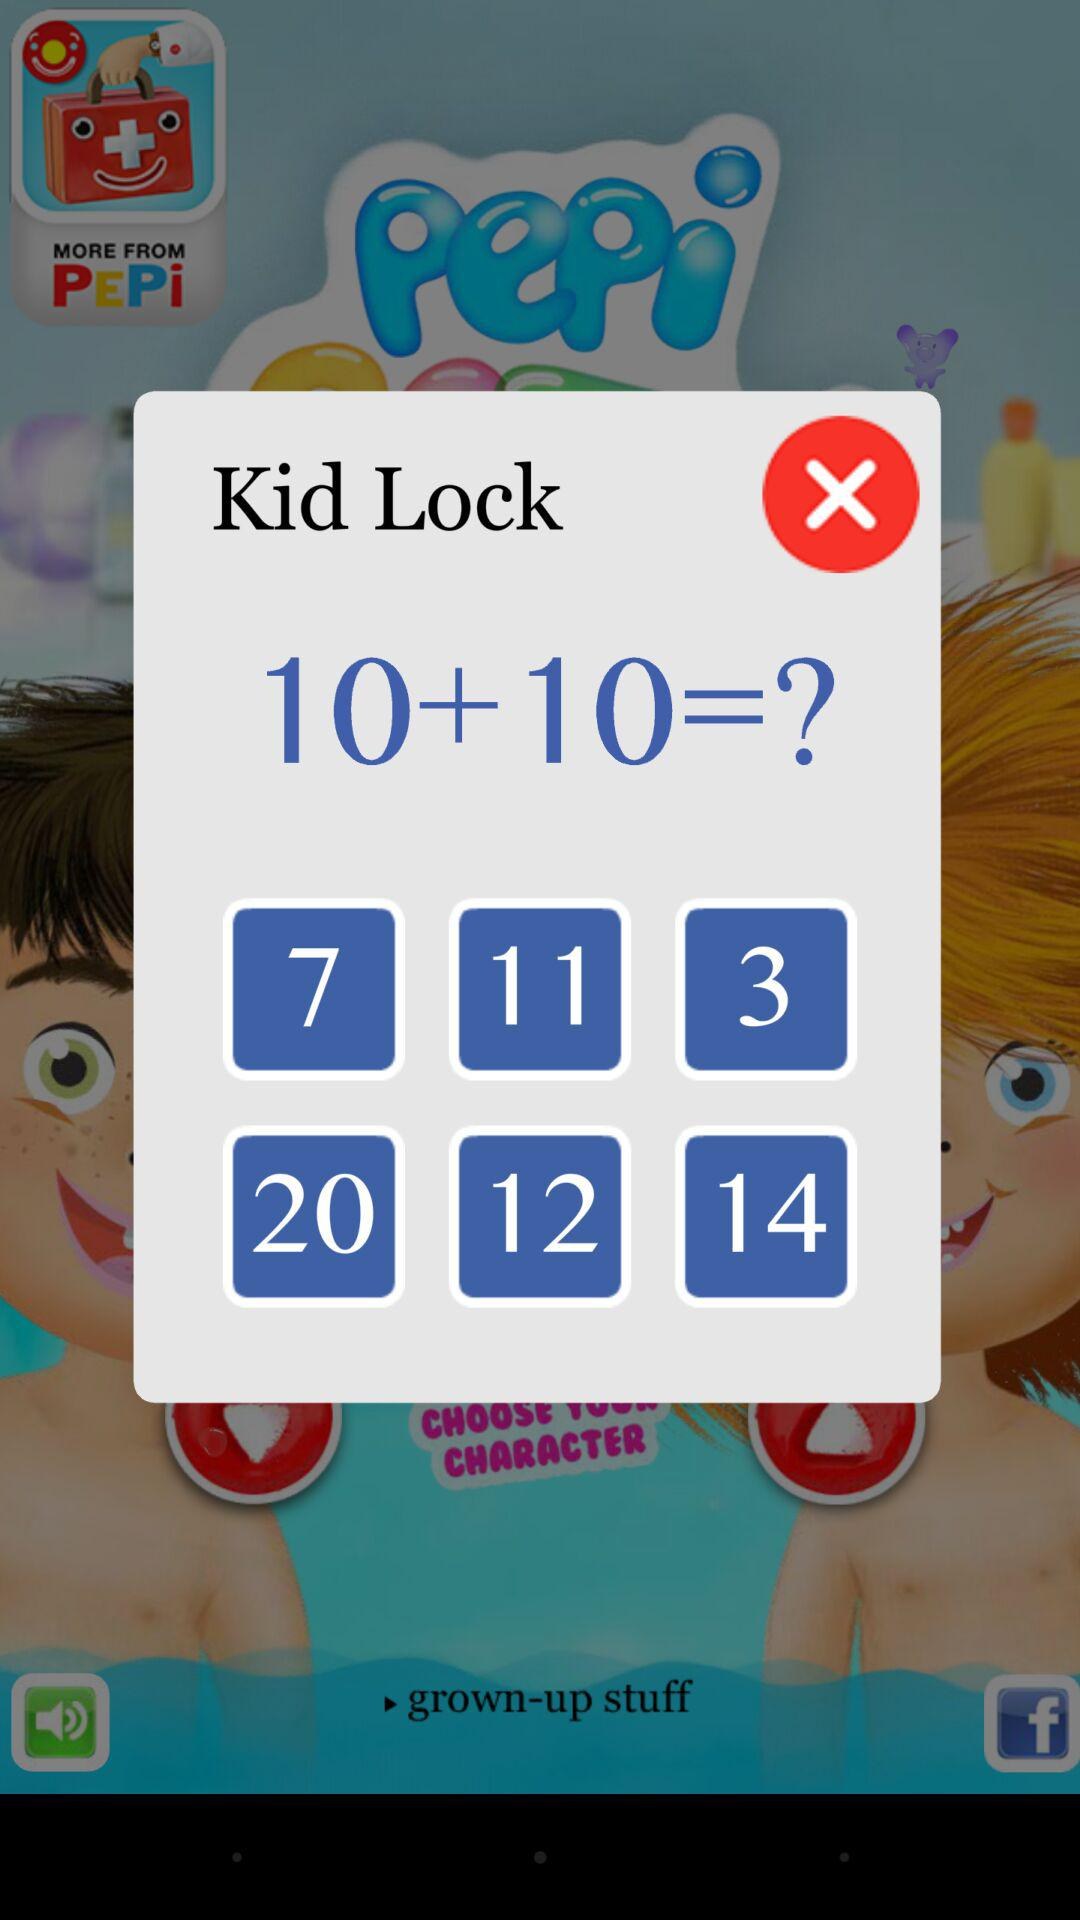What is the sum of the numbers in the question?
Answer the question using a single word or phrase. 20 